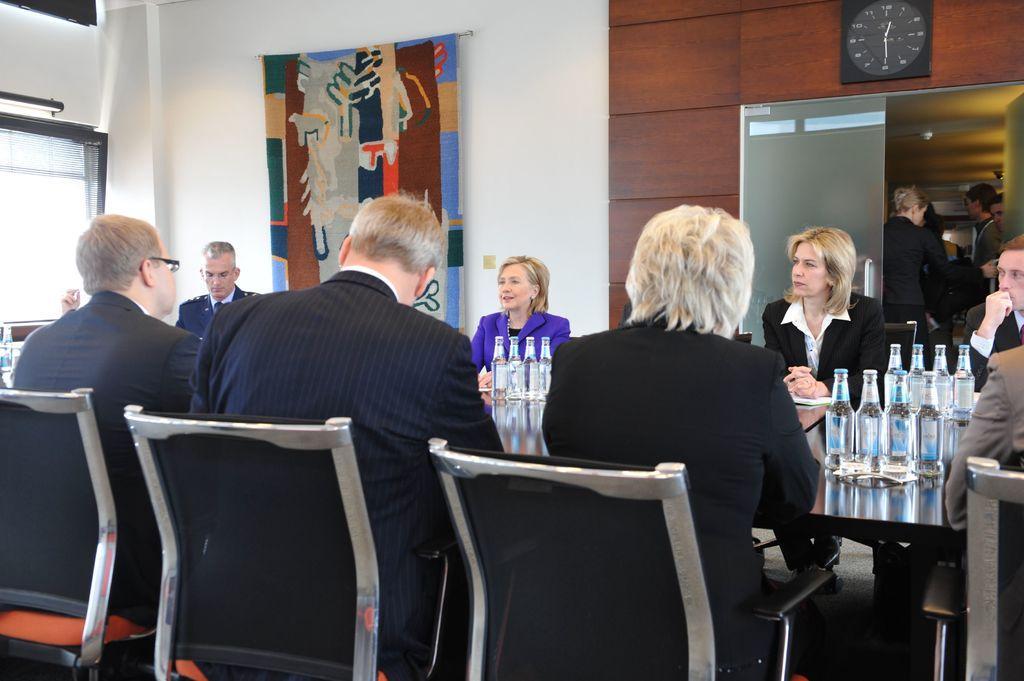In one or two sentences, can you explain what this image depicts? There are many persons sitting on the chairs. In front of them there is a table. On the table there are many bottles. In the background there is a wall. On the wall there is a banner, clock ,door. And there are many people standing in the background. Also on the left side there is a window. 